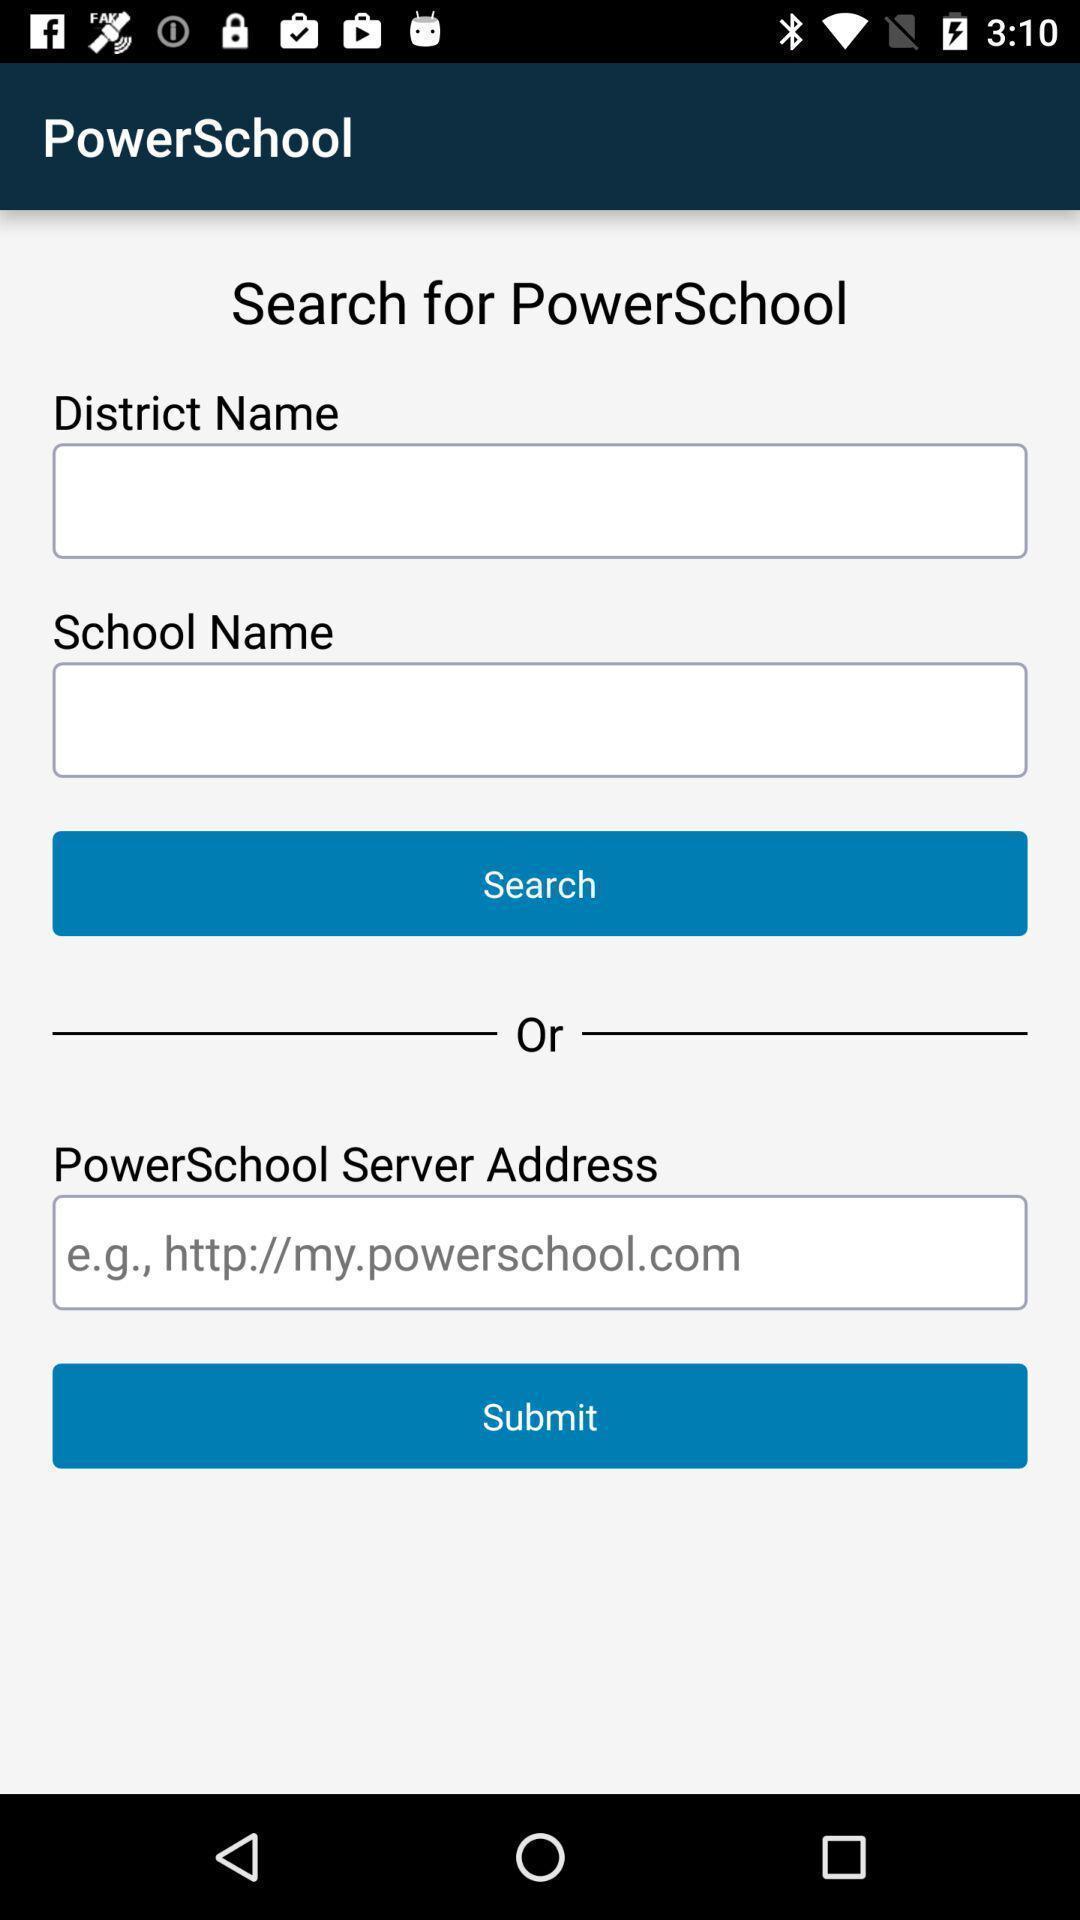Explain what's happening in this screen capture. Search page for a student application. 